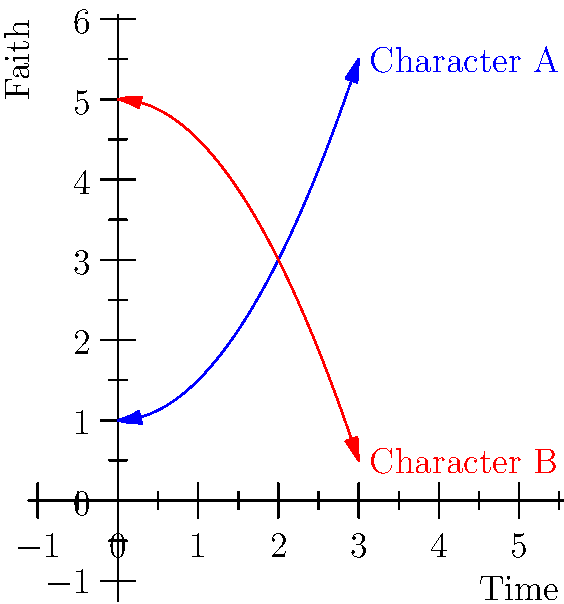In the context of a religious narrative, the graph above represents the faith journey of two characters over time. Which character's arc would likely provide a more compelling story for a reverend to share in a sermon, and why? To answer this question, we need to analyze the character arcs represented by the two lines:

1. Blue line (Character A):
   - Starts at a lower point of faith
   - Shows a steady increase in faith over time
   - The curve is convex, indicating accelerating growth

2. Red line (Character B):
   - Starts at a higher point of faith
   - Shows a gradual decline in faith over time
   - The curve is concave, indicating a deceleration in the loss of faith

3. Storytelling perspective:
   - Character A's journey represents a classic redemption arc or spiritual awakening
   - This arc aligns well with themes of hope, perseverance, and the transformative power of faith
   - Such stories often resonate strongly with congregations and provide clear moral lessons

4. Reverend's perspective:
   - A reverend would likely find Character A's story more compelling to share in a sermon
   - It demonstrates the positive impact of faith and spiritual growth
   - The arc can be used to encourage and inspire the congregation

5. Writer's perspective:
   - As a writer inspired by the reverend's storytelling, Character A's arc provides more opportunities for dramatic moments and character development
   - The upward trajectory allows for exploration of pivotal moments that strengthen faith

Therefore, Character A's arc would likely provide a more compelling story for a reverend to share in a sermon, as it aligns better with themes of spiritual growth and redemption, which are central to many religious narratives.
Answer: Character A, due to the upward faith trajectory representing spiritual growth and redemption. 